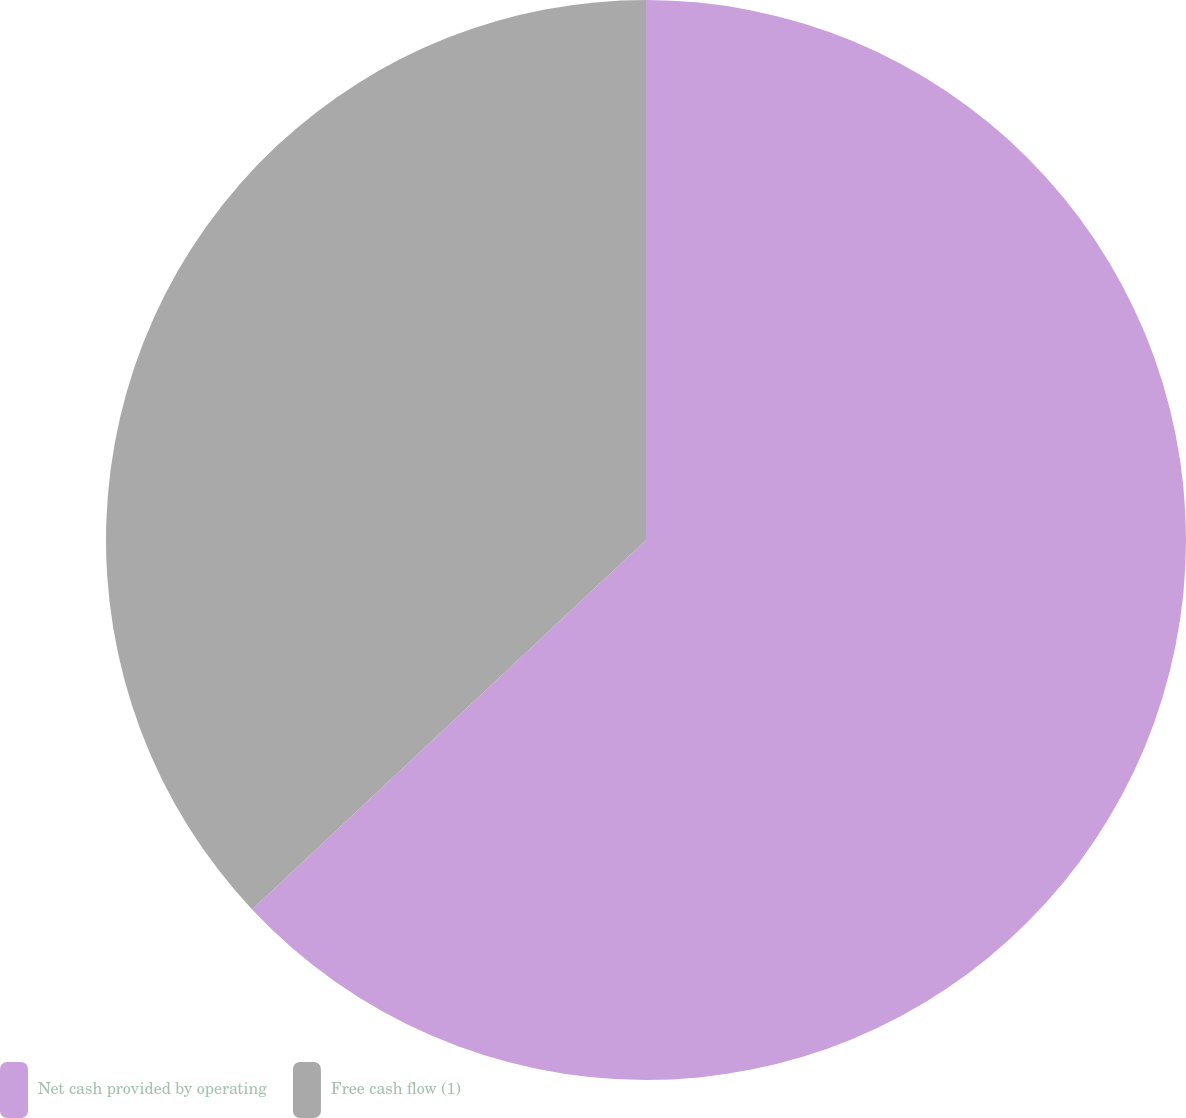<chart> <loc_0><loc_0><loc_500><loc_500><pie_chart><fcel>Net cash provided by operating<fcel>Free cash flow (1)<nl><fcel>63.01%<fcel>36.99%<nl></chart> 